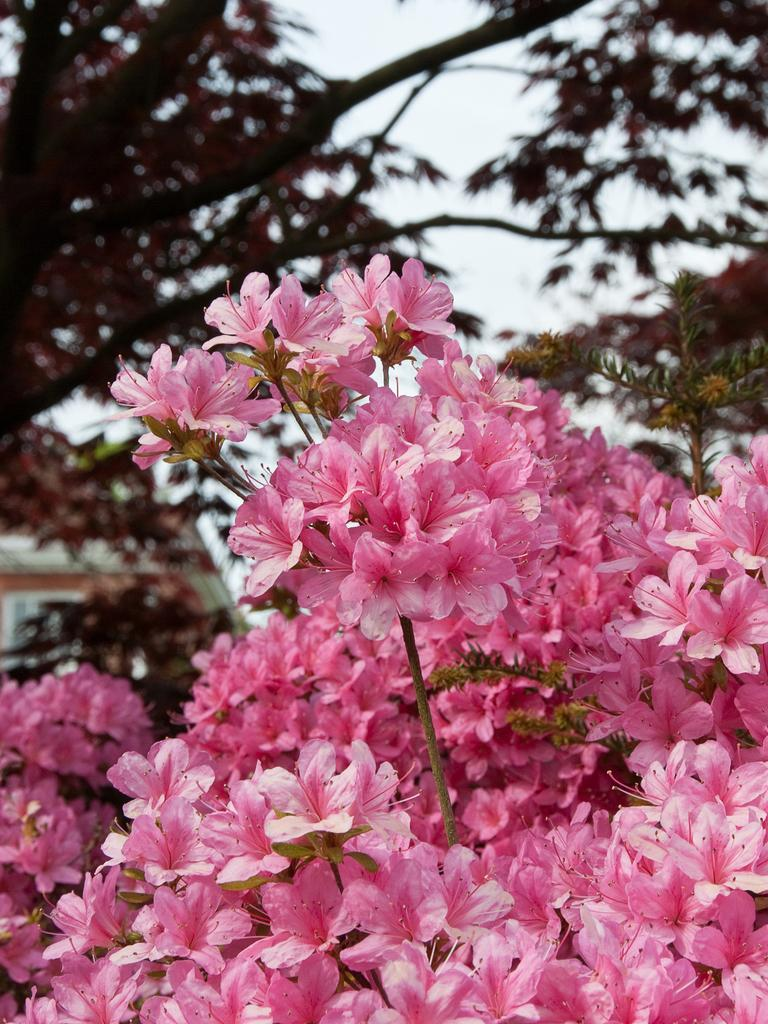What type of flowers can be seen in the image? There are pink color flowers in the image. What can be seen in the background of the image? There are trees and the sky visible in the background of the image. How much money is being exchanged between the flowers in the image? There is no money present in the image, as it features flowers and a background with trees and the sky. 